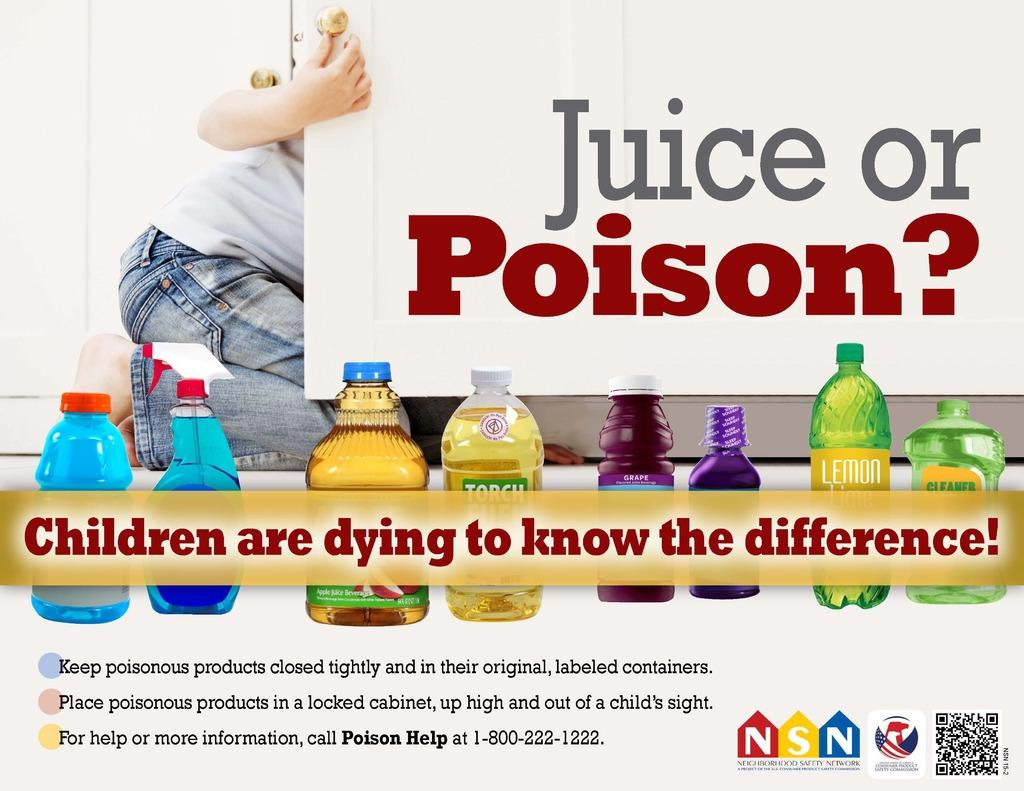Provide a one-sentence caption for the provided image. Juice or Poison advertisement to keep poisonous products away from children and to keep it in a locked cabinet. 